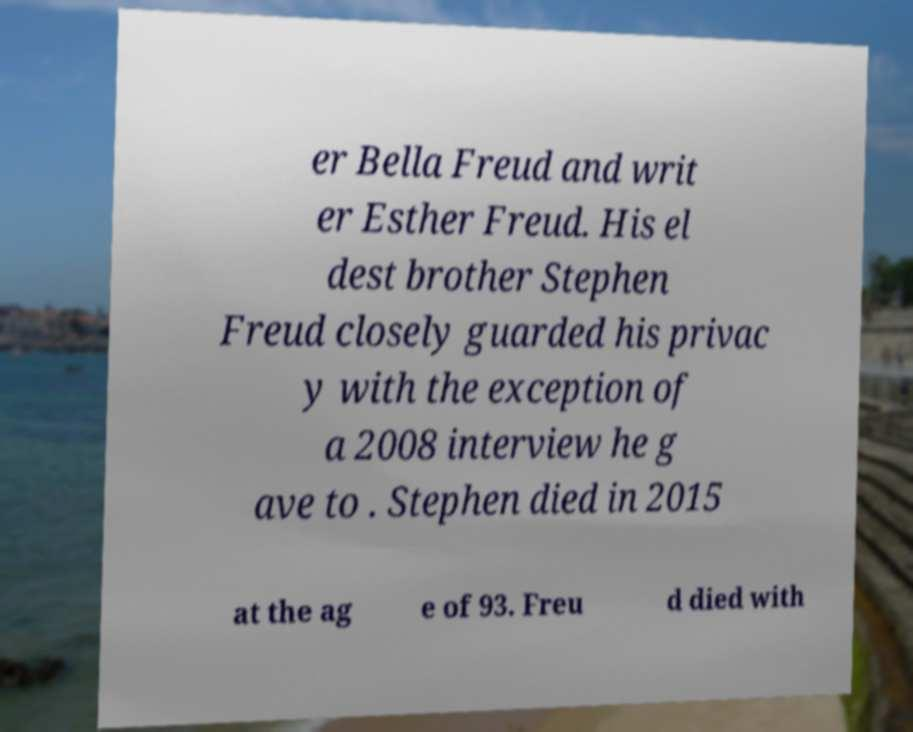There's text embedded in this image that I need extracted. Can you transcribe it verbatim? er Bella Freud and writ er Esther Freud. His el dest brother Stephen Freud closely guarded his privac y with the exception of a 2008 interview he g ave to . Stephen died in 2015 at the ag e of 93. Freu d died with 